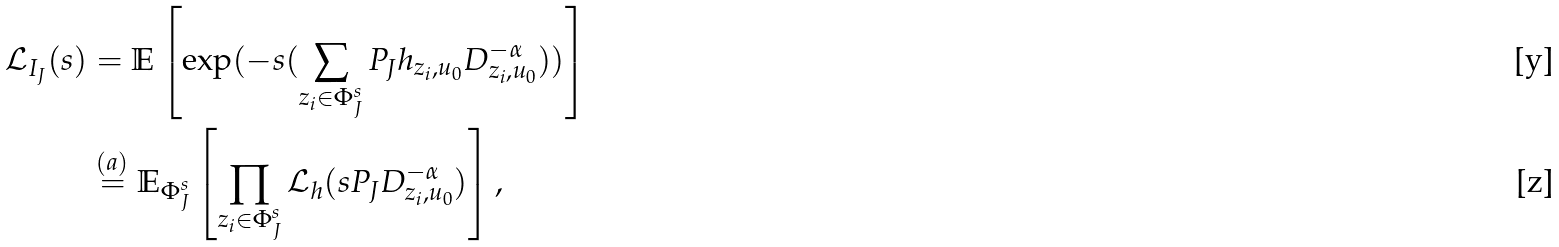<formula> <loc_0><loc_0><loc_500><loc_500>\mathcal { L } _ { I _ { J } } ( s ) & = \mathbb { E } \left [ \exp ( - s ( \sum _ { z _ { i } \in \Phi _ { J } ^ { s } } P _ { J } h _ { z _ { i } , u _ { 0 } } D _ { z _ { i } , u _ { 0 } } ^ { - \alpha } ) ) \right ] \\ & \overset { ( a ) } { = } \mathbb { E } _ { \Phi _ { J } ^ { s } } \left [ \prod _ { z _ { i } \in \Phi _ { J } ^ { s } } \mathcal { L } _ { h } ( s P _ { J } D _ { z _ { i } , u _ { 0 } } ^ { - \alpha } ) \right ] ,</formula> 